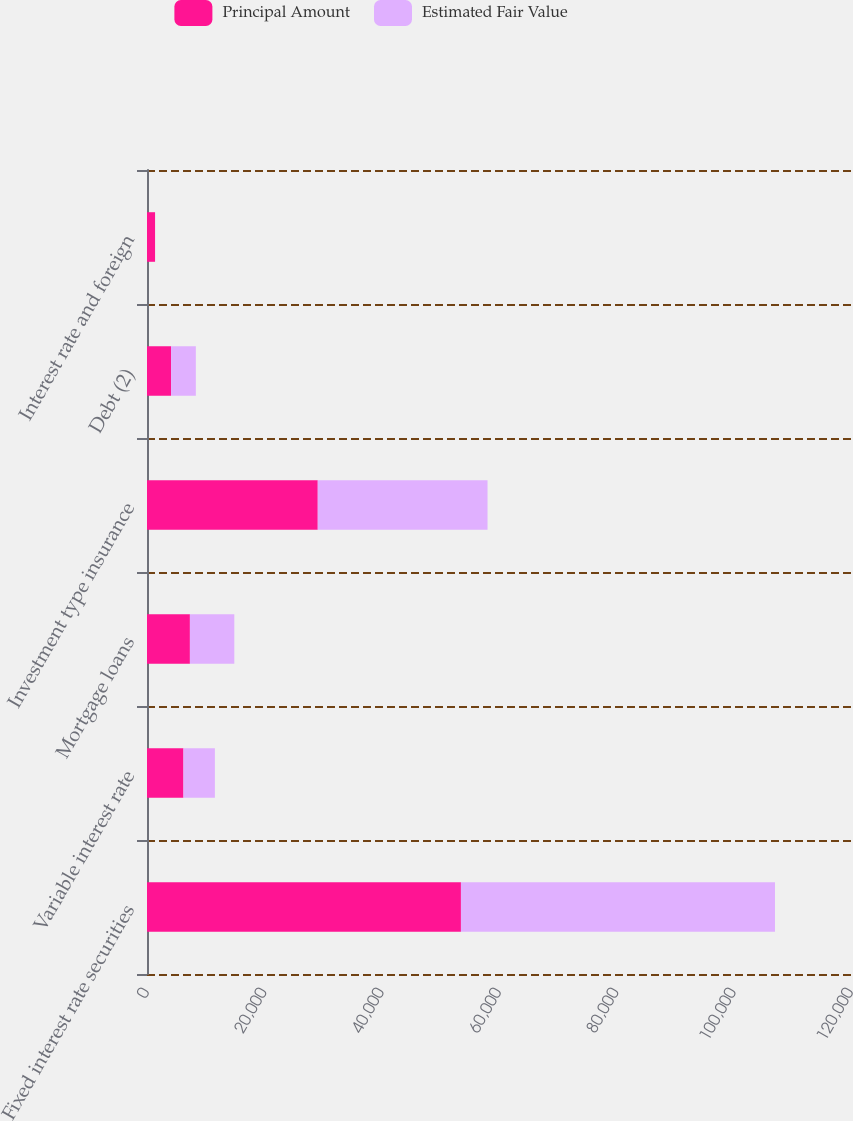<chart> <loc_0><loc_0><loc_500><loc_500><stacked_bar_chart><ecel><fcel>Fixed interest rate securities<fcel>Variable interest rate<fcel>Mortgage loans<fcel>Investment type insurance<fcel>Debt (2)<fcel>Interest rate and foreign<nl><fcel>Principal Amount<fcel>53512<fcel>6215<fcel>7313<fcel>29107<fcel>4106<fcel>1374<nl><fcel>Estimated Fair Value<fcel>53530<fcel>5358<fcel>7570<fcel>28939<fcel>4219<fcel>1<nl></chart> 